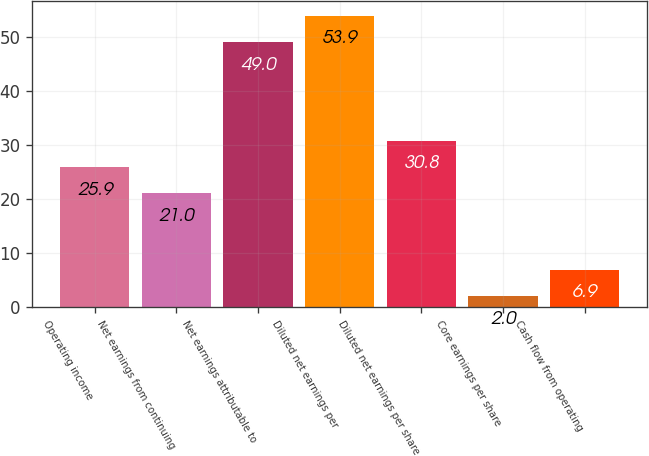Convert chart. <chart><loc_0><loc_0><loc_500><loc_500><bar_chart><fcel>Operating income<fcel>Net earnings from continuing<fcel>Net earnings attributable to<fcel>Diluted net earnings per<fcel>Diluted net earnings per share<fcel>Core earnings per share<fcel>Cash flow from operating<nl><fcel>25.9<fcel>21<fcel>49<fcel>53.9<fcel>30.8<fcel>2<fcel>6.9<nl></chart> 